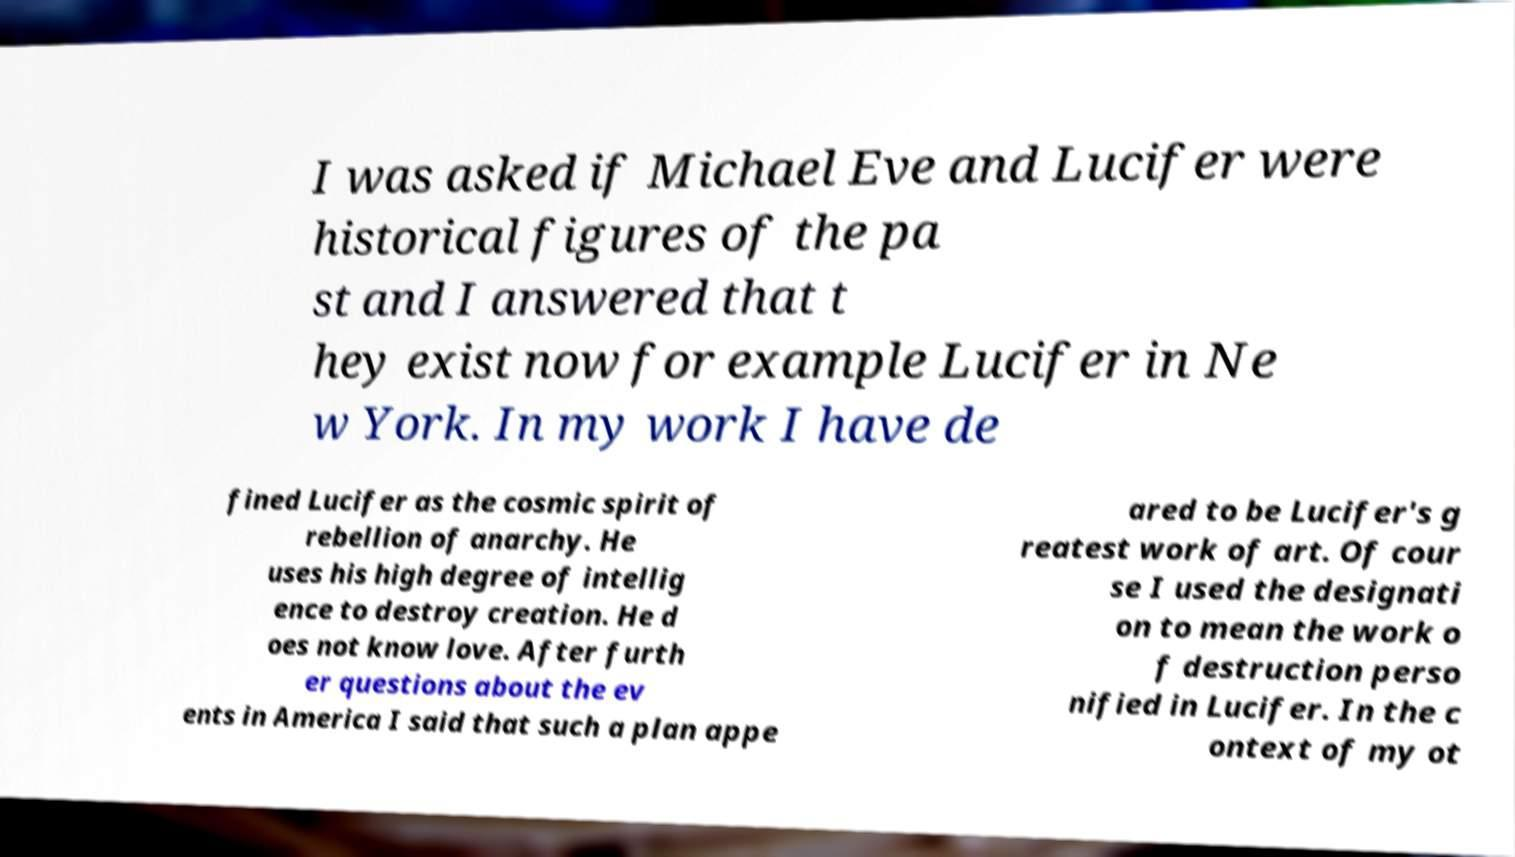Please identify and transcribe the text found in this image. I was asked if Michael Eve and Lucifer were historical figures of the pa st and I answered that t hey exist now for example Lucifer in Ne w York. In my work I have de fined Lucifer as the cosmic spirit of rebellion of anarchy. He uses his high degree of intellig ence to destroy creation. He d oes not know love. After furth er questions about the ev ents in America I said that such a plan appe ared to be Lucifer's g reatest work of art. Of cour se I used the designati on to mean the work o f destruction perso nified in Lucifer. In the c ontext of my ot 